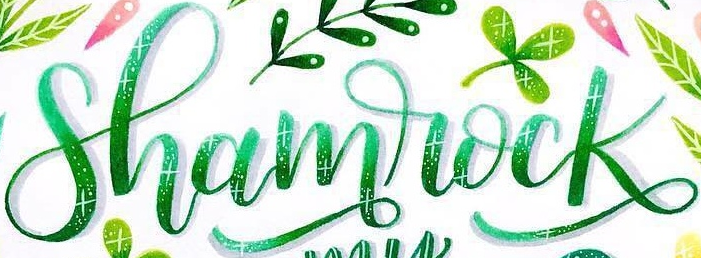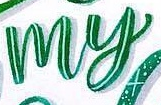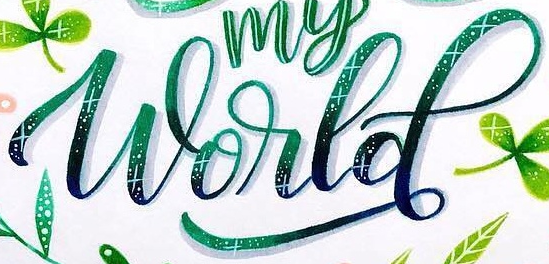What text appears in these images from left to right, separated by a semicolon? Shamrock; my; World 